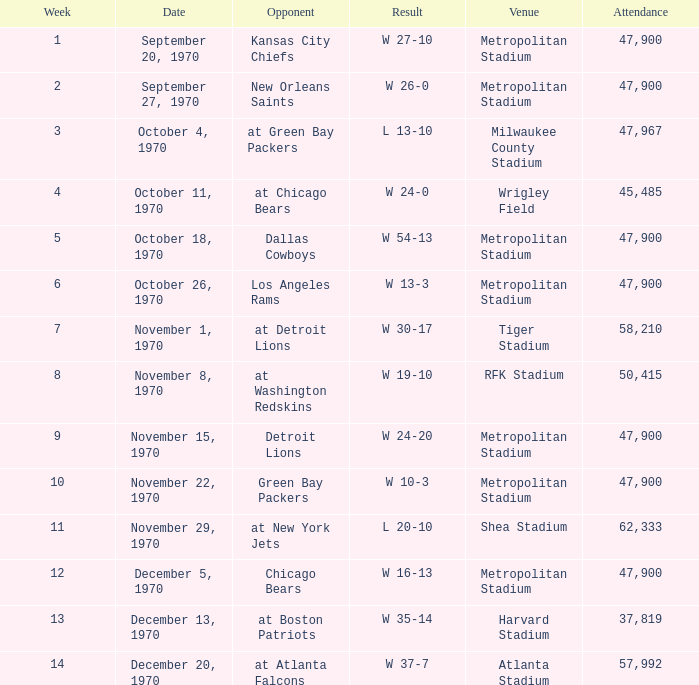What was the number of attendees at the match with a 16-13 win and held one week earlier than week 12? None. 